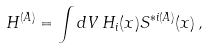Convert formula to latex. <formula><loc_0><loc_0><loc_500><loc_500>H ^ { ( A ) } = \int d V \, H _ { i } ( x ) S ^ { * i ( A ) } ( x ) \, ,</formula> 